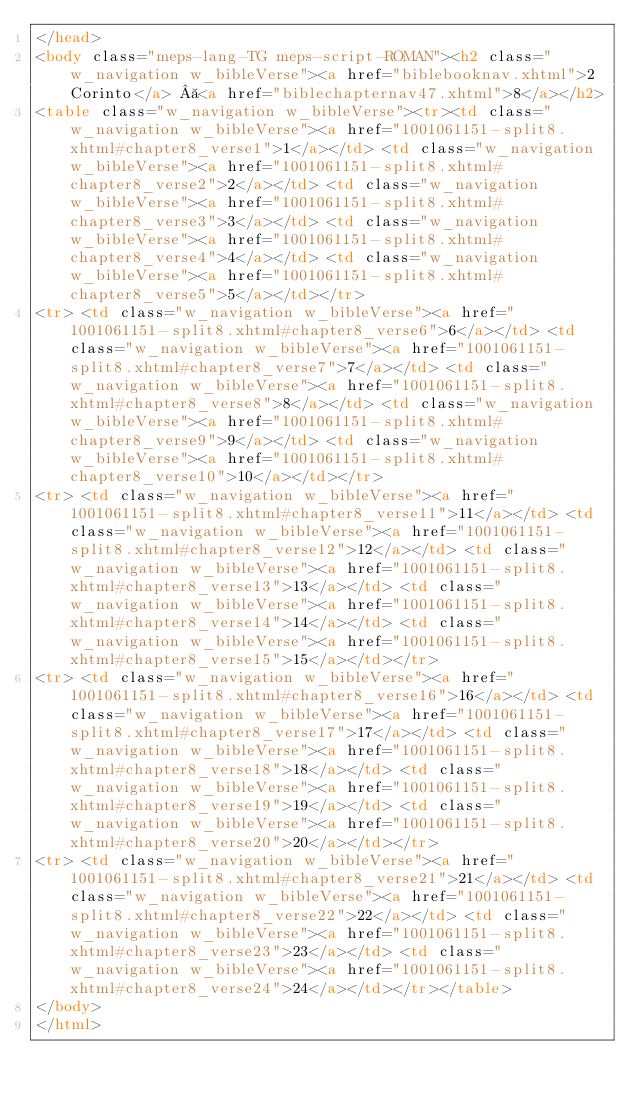<code> <loc_0><loc_0><loc_500><loc_500><_HTML_></head>
<body class="meps-lang-TG meps-script-ROMAN"><h2 class="w_navigation w_bibleVerse"><a href="biblebooknav.xhtml">2 Corinto</a>  <a href="biblechapternav47.xhtml">8</a></h2>
<table class="w_navigation w_bibleVerse"><tr><td class="w_navigation w_bibleVerse"><a href="1001061151-split8.xhtml#chapter8_verse1">1</a></td> <td class="w_navigation w_bibleVerse"><a href="1001061151-split8.xhtml#chapter8_verse2">2</a></td> <td class="w_navigation w_bibleVerse"><a href="1001061151-split8.xhtml#chapter8_verse3">3</a></td> <td class="w_navigation w_bibleVerse"><a href="1001061151-split8.xhtml#chapter8_verse4">4</a></td> <td class="w_navigation w_bibleVerse"><a href="1001061151-split8.xhtml#chapter8_verse5">5</a></td></tr>
<tr> <td class="w_navigation w_bibleVerse"><a href="1001061151-split8.xhtml#chapter8_verse6">6</a></td> <td class="w_navigation w_bibleVerse"><a href="1001061151-split8.xhtml#chapter8_verse7">7</a></td> <td class="w_navigation w_bibleVerse"><a href="1001061151-split8.xhtml#chapter8_verse8">8</a></td> <td class="w_navigation w_bibleVerse"><a href="1001061151-split8.xhtml#chapter8_verse9">9</a></td> <td class="w_navigation w_bibleVerse"><a href="1001061151-split8.xhtml#chapter8_verse10">10</a></td></tr>
<tr> <td class="w_navigation w_bibleVerse"><a href="1001061151-split8.xhtml#chapter8_verse11">11</a></td> <td class="w_navigation w_bibleVerse"><a href="1001061151-split8.xhtml#chapter8_verse12">12</a></td> <td class="w_navigation w_bibleVerse"><a href="1001061151-split8.xhtml#chapter8_verse13">13</a></td> <td class="w_navigation w_bibleVerse"><a href="1001061151-split8.xhtml#chapter8_verse14">14</a></td> <td class="w_navigation w_bibleVerse"><a href="1001061151-split8.xhtml#chapter8_verse15">15</a></td></tr>
<tr> <td class="w_navigation w_bibleVerse"><a href="1001061151-split8.xhtml#chapter8_verse16">16</a></td> <td class="w_navigation w_bibleVerse"><a href="1001061151-split8.xhtml#chapter8_verse17">17</a></td> <td class="w_navigation w_bibleVerse"><a href="1001061151-split8.xhtml#chapter8_verse18">18</a></td> <td class="w_navigation w_bibleVerse"><a href="1001061151-split8.xhtml#chapter8_verse19">19</a></td> <td class="w_navigation w_bibleVerse"><a href="1001061151-split8.xhtml#chapter8_verse20">20</a></td></tr>
<tr> <td class="w_navigation w_bibleVerse"><a href="1001061151-split8.xhtml#chapter8_verse21">21</a></td> <td class="w_navigation w_bibleVerse"><a href="1001061151-split8.xhtml#chapter8_verse22">22</a></td> <td class="w_navigation w_bibleVerse"><a href="1001061151-split8.xhtml#chapter8_verse23">23</a></td> <td class="w_navigation w_bibleVerse"><a href="1001061151-split8.xhtml#chapter8_verse24">24</a></td></tr></table>
</body>
</html>
</code> 